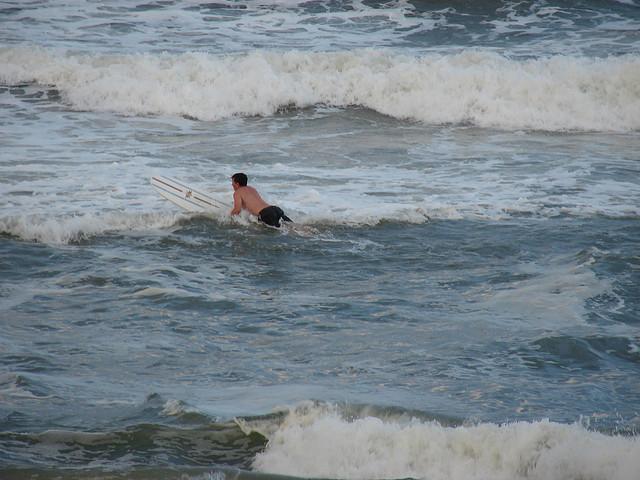How many people do you see?
Give a very brief answer. 1. 